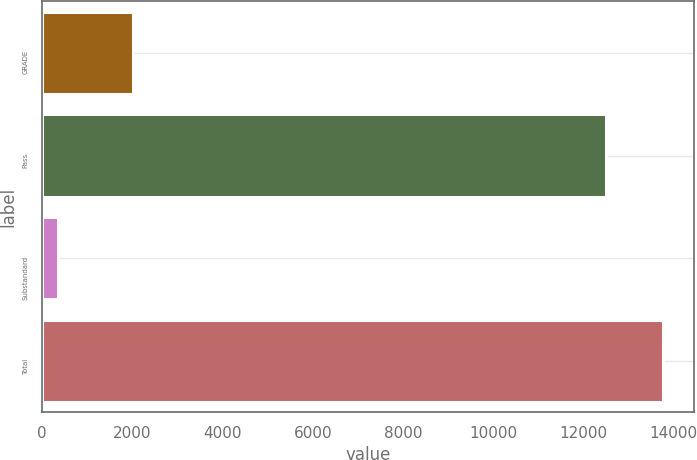Convert chart to OTSL. <chart><loc_0><loc_0><loc_500><loc_500><bar_chart><fcel>GRADE<fcel>Pass<fcel>Substandard<fcel>Total<nl><fcel>2013<fcel>12500<fcel>346<fcel>13750<nl></chart> 